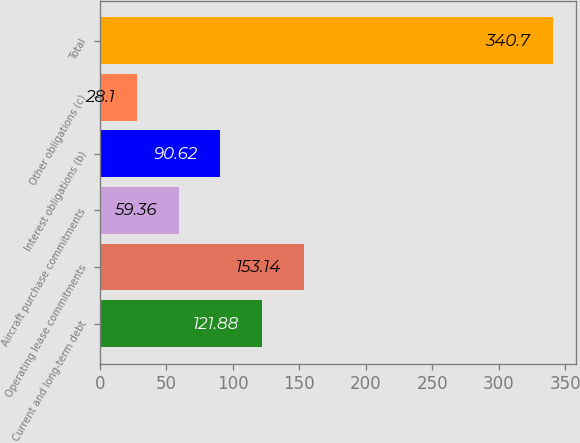Convert chart. <chart><loc_0><loc_0><loc_500><loc_500><bar_chart><fcel>Current and long-term debt<fcel>Operating lease commitments<fcel>Aircraft purchase commitments<fcel>Interest obligations (b)<fcel>Other obligations (c)<fcel>Total<nl><fcel>121.88<fcel>153.14<fcel>59.36<fcel>90.62<fcel>28.1<fcel>340.7<nl></chart> 